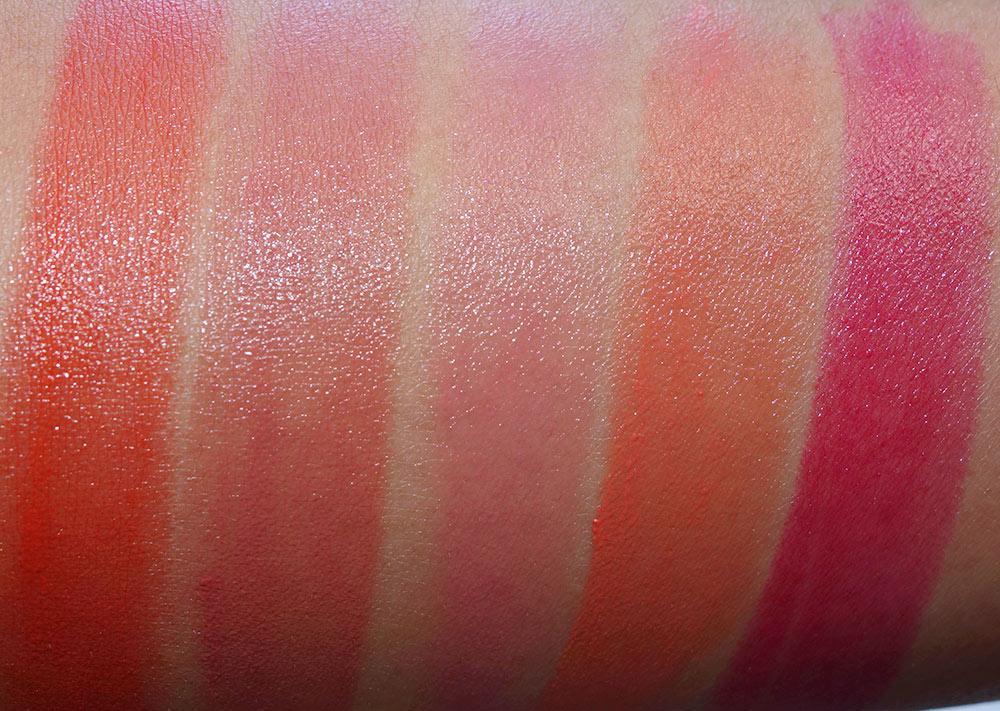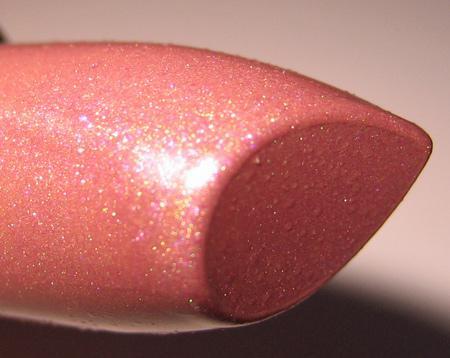The first image is the image on the left, the second image is the image on the right. Evaluate the accuracy of this statement regarding the images: "There are at least 13 stripes of different lipstick colors on the arms.". Is it true? Answer yes or no. No. The first image is the image on the left, the second image is the image on the right. Examine the images to the left and right. Is the description "The person on the left is lighter skinned than the person on the right." accurate? Answer yes or no. No. 